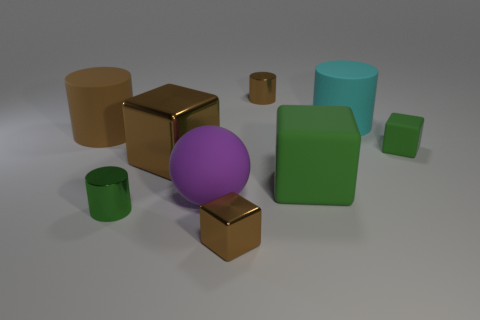Add 1 big purple objects. How many objects exist? 10 Subtract all cubes. How many objects are left? 5 Add 6 small objects. How many small objects are left? 10 Add 7 cyan objects. How many cyan objects exist? 8 Subtract 1 green cubes. How many objects are left? 8 Subtract all tiny matte cubes. Subtract all big rubber spheres. How many objects are left? 7 